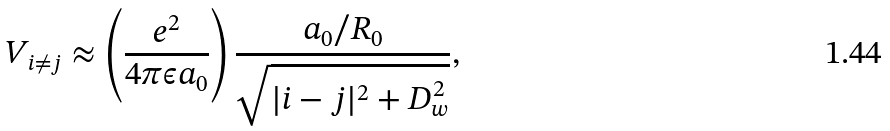<formula> <loc_0><loc_0><loc_500><loc_500>V _ { i \neq j } \approx \left ( \frac { e ^ { 2 } } { 4 \pi \epsilon a _ { 0 } } \right ) \frac { a _ { 0 } / R _ { 0 } } { \sqrt { | i - j | ^ { 2 } + D _ { w } ^ { 2 } } } ,</formula> 